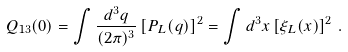Convert formula to latex. <formula><loc_0><loc_0><loc_500><loc_500>Q _ { 1 3 } ( 0 ) = \int \frac { d ^ { 3 } q } { ( 2 \pi ) ^ { 3 } } \left [ P _ { L } ( q ) \right ] ^ { 2 } = \int d ^ { 3 } x \left [ \xi _ { L } ( x ) \right ] ^ { 2 } \, .</formula> 